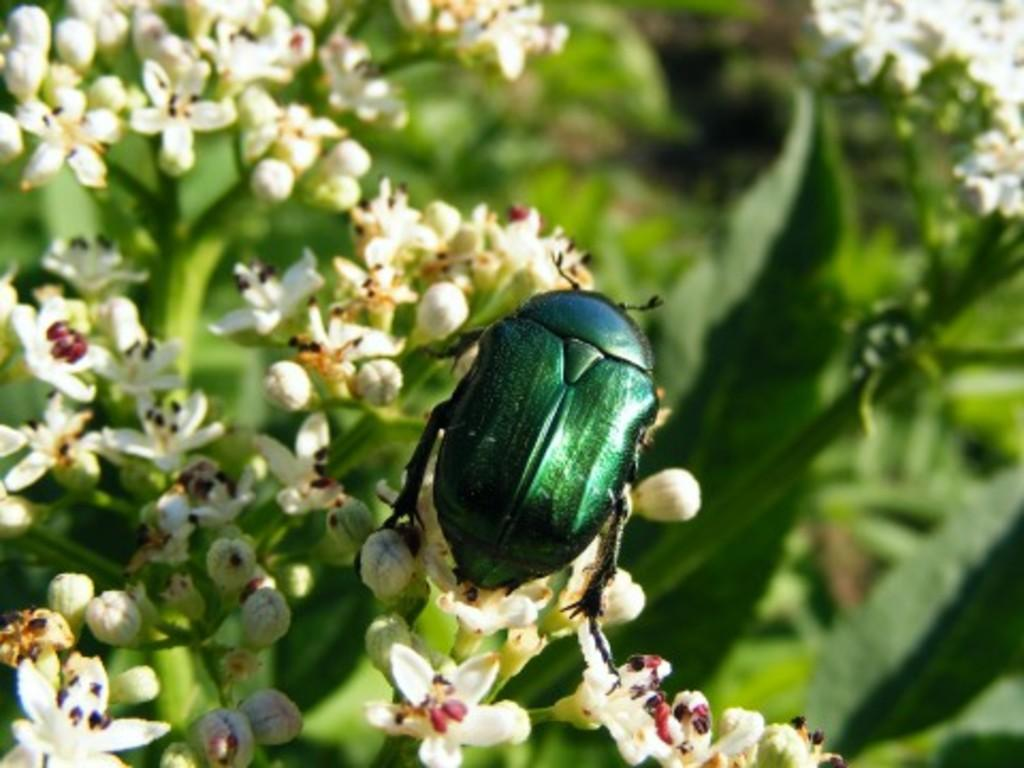What type of plants are present in the image? The plants in the image have flowers and buds. Can you describe the flowers on the plants? The flowers on the plants are visible in the image. Are there any other living organisms present on the plants? Yes, there is an insect on the flowers in the image. How many lizards can be seen basking in the sun on the plants in the image? There are no lizards visible in the image. 